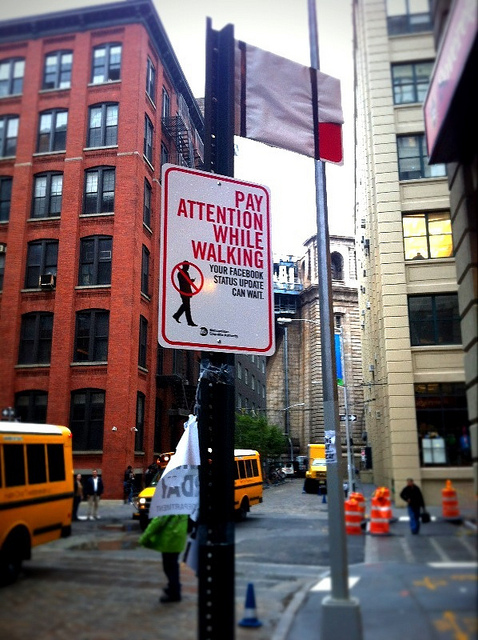Identify the text contained in this image. WALKING PAY ATTENTION WHILE WAIT STATUS CAN UPDATE FACEBOOK YOUR 